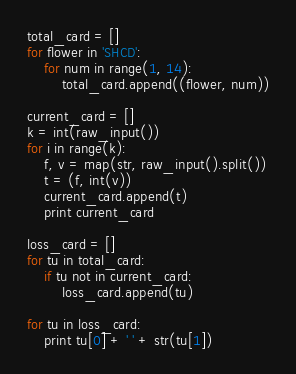Convert code to text. <code><loc_0><loc_0><loc_500><loc_500><_Python_>total_card = []
for flower in 'SHCD':
    for num in range(1, 14):
        total_card.append((flower, num))

current_card = []
k = int(raw_input())
for i in range(k):
    f, v = map(str, raw_input().split())
    t = (f, int(v))
    current_card.append(t)
    print current_card

loss_card = []
for tu in total_card:
    if tu not in current_card:
        loss_card.append(tu)

for tu in loss_card:
    print tu[0] + ' ' + str(tu[1])</code> 